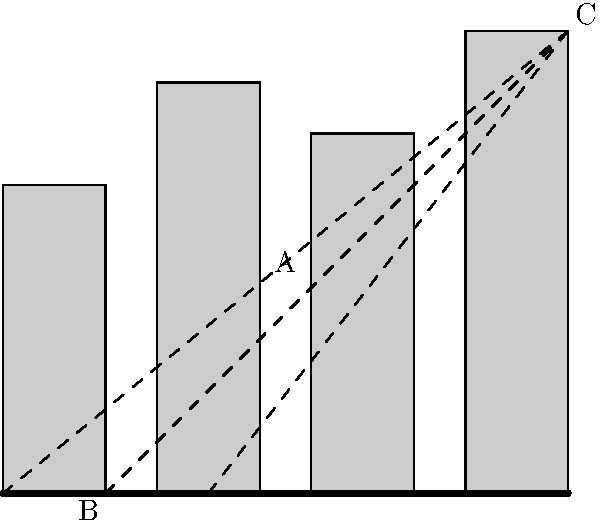In this urban cityscape, which element would be most effective as a leading line to guide the viewer's eye from point B to point C, enhancing the composition and creating a sense of depth? To determine the most effective leading line in this urban photograph, let's analyze the elements step-by-step:

1. Leading lines are compositional tools that guide the viewer's eye through the image, often towards a focal point.

2. In urban photography, leading lines can be created by various elements such as roads, building edges, or other linear structures.

3. The question asks about guiding the eye from point B (bottom left) to point C (top right), which suggests a diagonal movement across the frame.

4. In the image, we can identify three potential leading lines:
   a. The road at the bottom of the frame
   b. The edges of the buildings
   c. The dashed lines representing potential compositional lines

5. The road (a) is a strong horizontal line but doesn't lead directly to point C.

6. The building edges (b) create vertical lines that don't guide the eye diagonally.

7. The dashed lines (c) represent diagonal lines that lead directly from the bottom left (near B) to the top right (C).

8. Of these options, the diagonal lines (c) are the most effective for creating a sense of depth and guiding the viewer's eye from B to C.

9. These diagonal lines also intersect with the buildings at various points, including point A, which adds interest to the composition.

10. In practice, a photographer could use elements in the scene that align with these diagonal lines, such as a pedestrian crossing, shadows, or architectural features, to create this effect.
Answer: Diagonal lines from bottom left to top right 